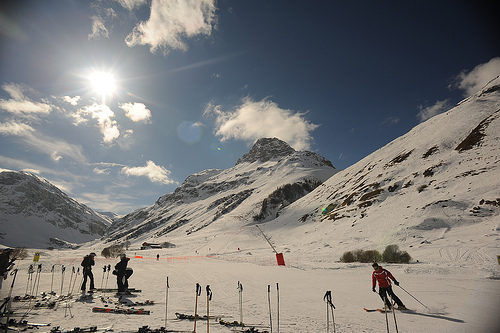Are there people to the right of the fence? No, there are no people located to the right of the fence; all skiers are visible to the left side or near the center of the image. 